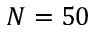<formula> <loc_0><loc_0><loc_500><loc_500>N = 5 0</formula> 